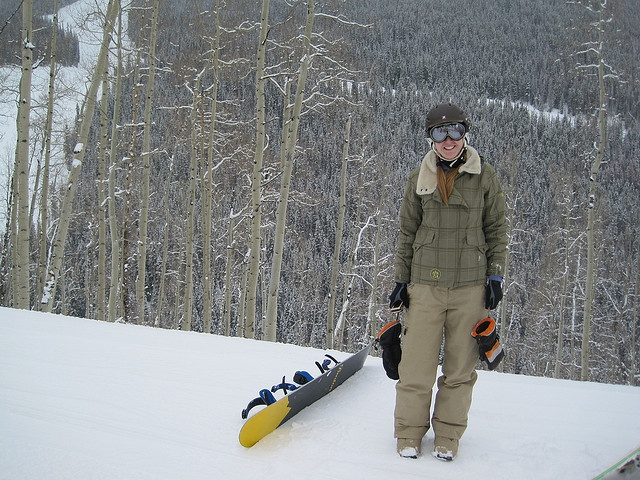Describe the objects in this image and their specific colors. I can see people in gray and black tones and snowboard in gray, olive, black, and navy tones in this image. 